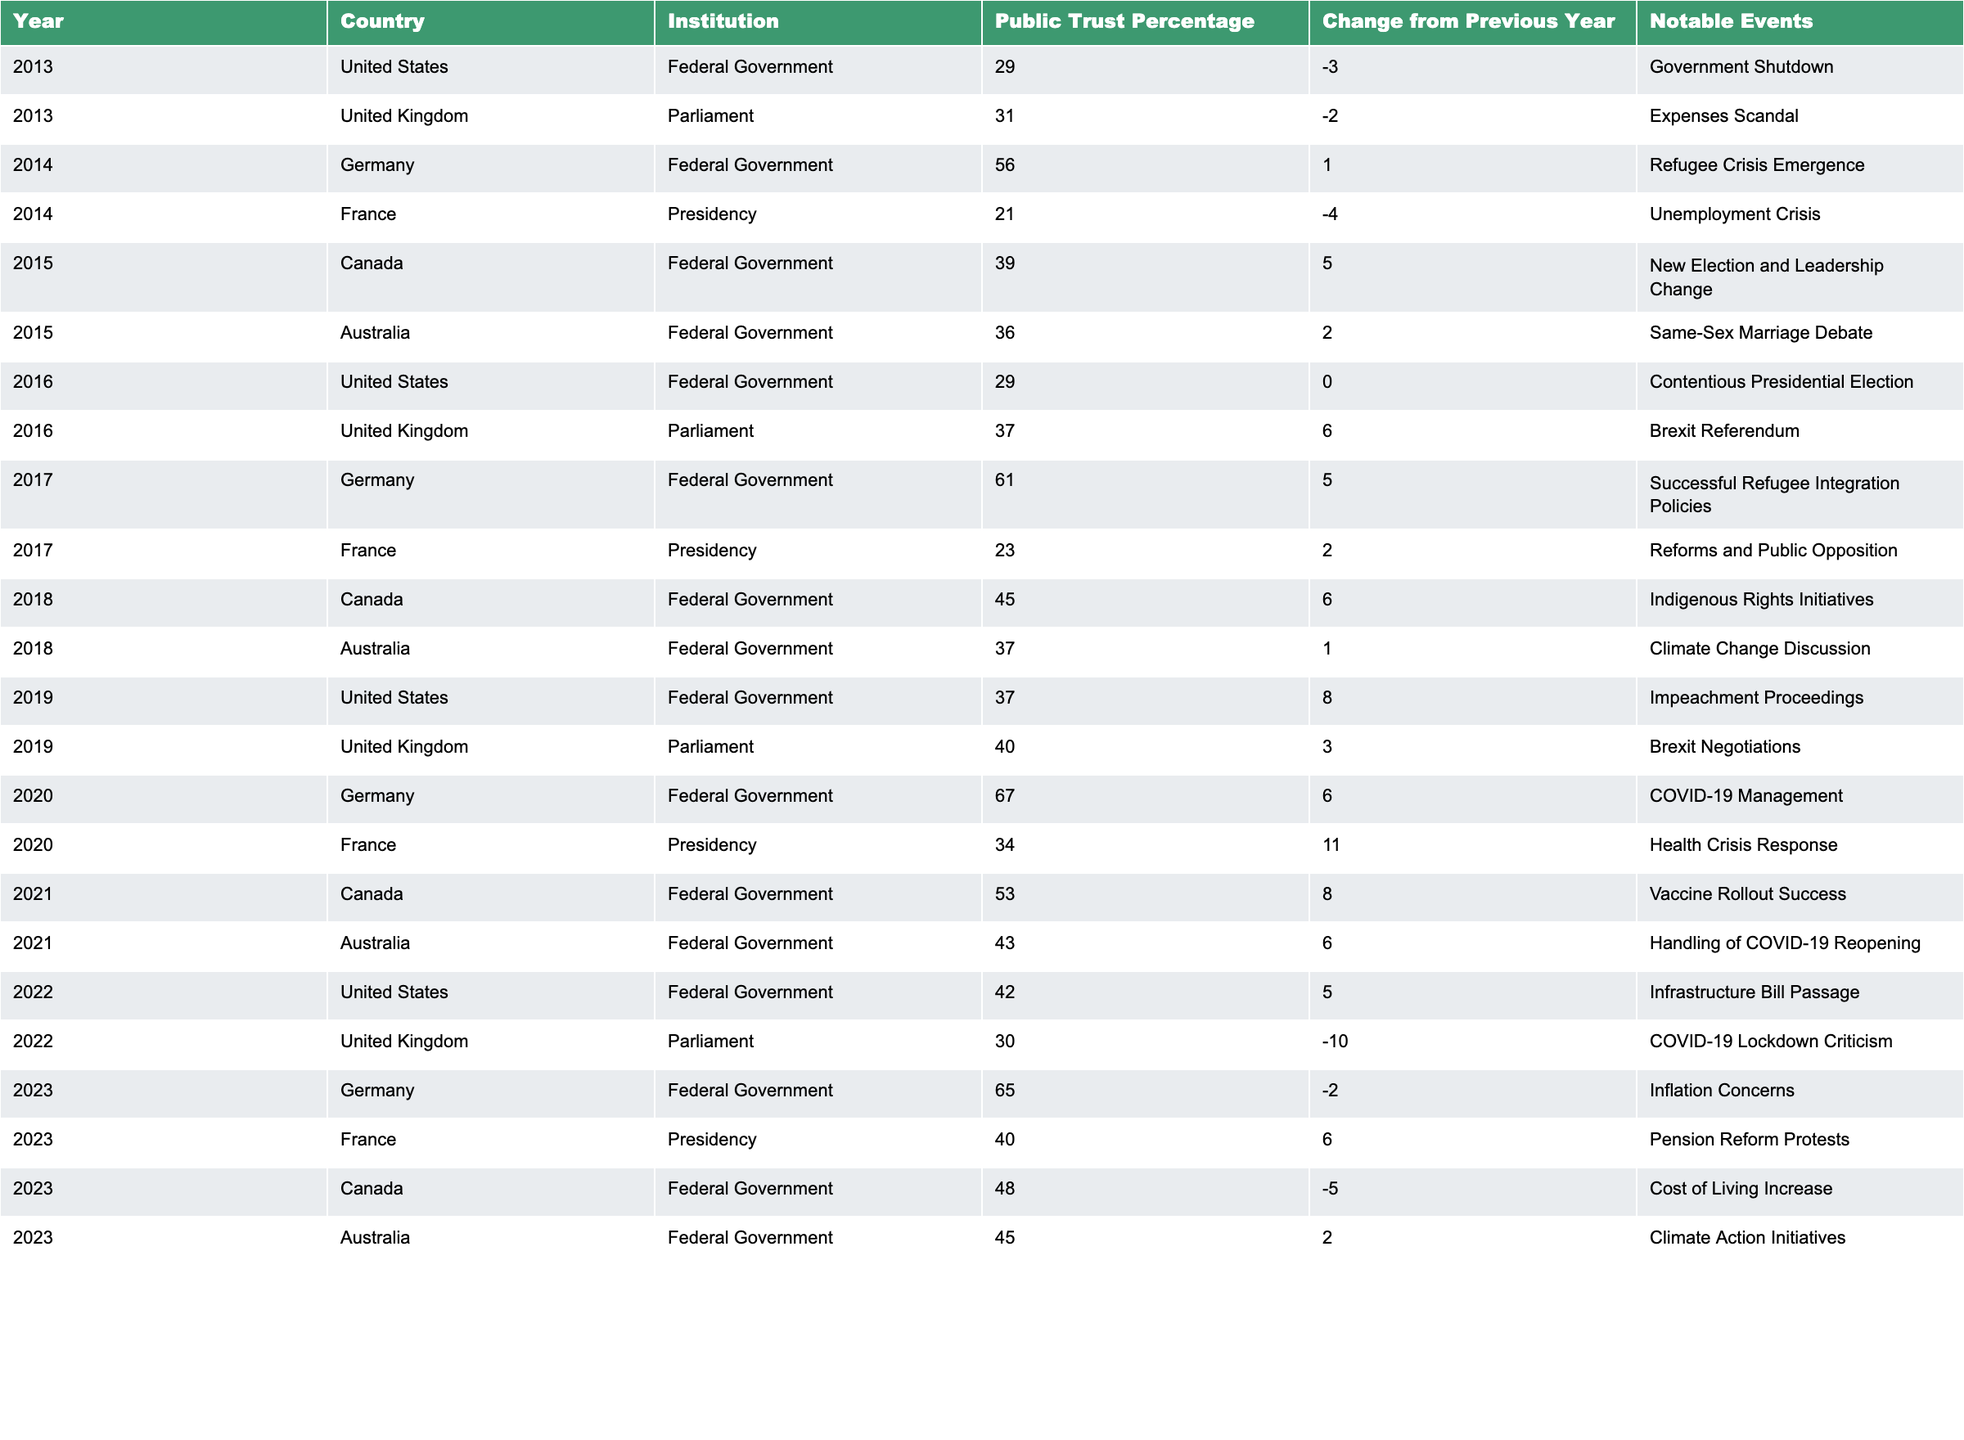What year saw the highest public trust percentage in the Federal Government of Germany? By examining the table, we see that the Federal Government of Germany had a public trust percentage of 67 in 2020, which is the highest value listed for that institution over the years shown.
Answer: 2020 What was the change in public trust percentage for the United Kingdom's Parliament from 2022 to 2023? The public trust percentage for the United Kingdom's Parliament was 30 in 2022 and 30 in 2023 (30 - 30 = 0). Therefore, there was no change in the trust percentage between these two years.
Answer: 0 Which country had a public trust percentage increase of 11% in a single year, and in which year did this occur? Looking through the table, I see that France's Presidency had a trust percentage increase of 11% in 2020, moving from 23% to 34%.
Answer: France, 2020 Did the public trust percentage for the Federal Government of Germany decrease in 2023? According to the table, the Federal Government of Germany had a public trust percentage of 65 in 2023, down from 67 in 2022, indicating it did indeed decrease.
Answer: Yes What was the average public trust percentage for the Federal Government across all countries in 2015? To find the average, I add the trust percentages for Federal Governments in that year: Canada (39) + Australia (36) = 75. We then divide by the two data points (75 / 2 = 37.5).
Answer: 37.5 How does the change in public trust percentage in Australia from 2019 to 2020 compare to the change in the United States during the same period? In 2019, Australia's trust percentage was 37, and it rose to 43 in 2020, so the change was +6. For the United States, the percentage was 37 in 2019 and 42 in 2022, resulting in a +5 change. Since +6 is greater than +5, Australia's increase was more significant.
Answer: Australia's change was greater Which institution in Canada experienced the most significant increase in public trust from 2018 to 2019? From the table, I see that in Canada, the public trust percentage for the Federal Government rose from 45 in 2018 to 53 in 2021, giving a change of +8. No other institution's change exceeds that figure within the specified range.
Answer: Federal Government, +8 Out of the four countries listed in 2023, which had the highest public trust percentage, and what was that percentage? In 2023, Germany's Federal Government had the highest trust percentage of 65, while France, Canada, and Australia had 40, 48, and 45, respectively.
Answer: Germany, 65 Was the public trust percentage for the French Presidency higher in 2023 or 2020? The trust percentage for the French Presidency was 34 in 2020 and 40 in 2023. Since 40 is greater than 34, it confirms that the trust was higher in 2023.
Answer: Higher in 2023 